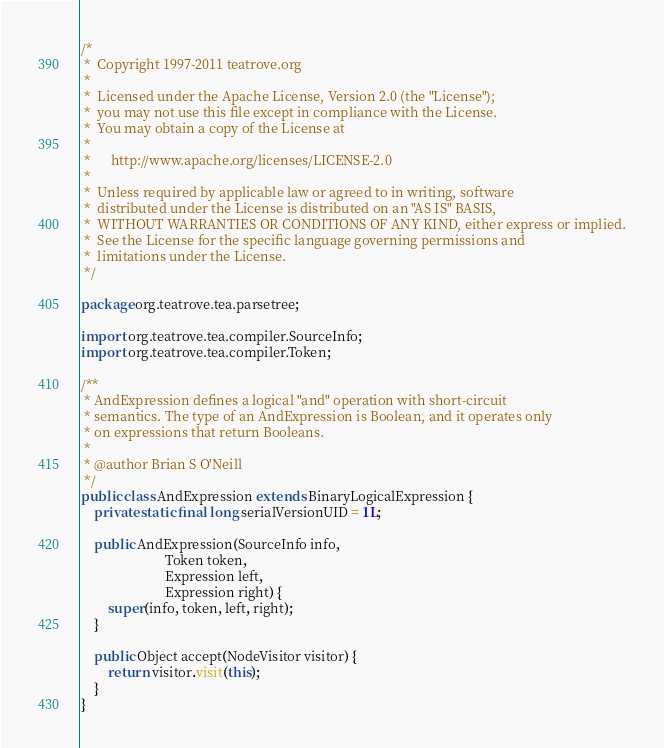<code> <loc_0><loc_0><loc_500><loc_500><_Java_>/*
 *  Copyright 1997-2011 teatrove.org
 *
 *  Licensed under the Apache License, Version 2.0 (the "License");
 *  you may not use this file except in compliance with the License.
 *  You may obtain a copy of the License at
 *
 *      http://www.apache.org/licenses/LICENSE-2.0
 *
 *  Unless required by applicable law or agreed to in writing, software
 *  distributed under the License is distributed on an "AS IS" BASIS,
 *  WITHOUT WARRANTIES OR CONDITIONS OF ANY KIND, either express or implied.
 *  See the License for the specific language governing permissions and
 *  limitations under the License.
 */

package org.teatrove.tea.parsetree;

import org.teatrove.tea.compiler.SourceInfo;
import org.teatrove.tea.compiler.Token;

/**
 * AndExpression defines a logical "and" operation with short-circuit 
 * semantics. The type of an AndExpression is Boolean, and it operates only
 * on expressions that return Booleans.
 *
 * @author Brian S O'Neill
 */
public class AndExpression extends BinaryLogicalExpression {
    private static final long serialVersionUID = 1L;

    public AndExpression(SourceInfo info,
                         Token token,
                         Expression left,
                         Expression right) {
        super(info, token, left, right);
    }

    public Object accept(NodeVisitor visitor) {
        return visitor.visit(this);
    }
}
</code> 